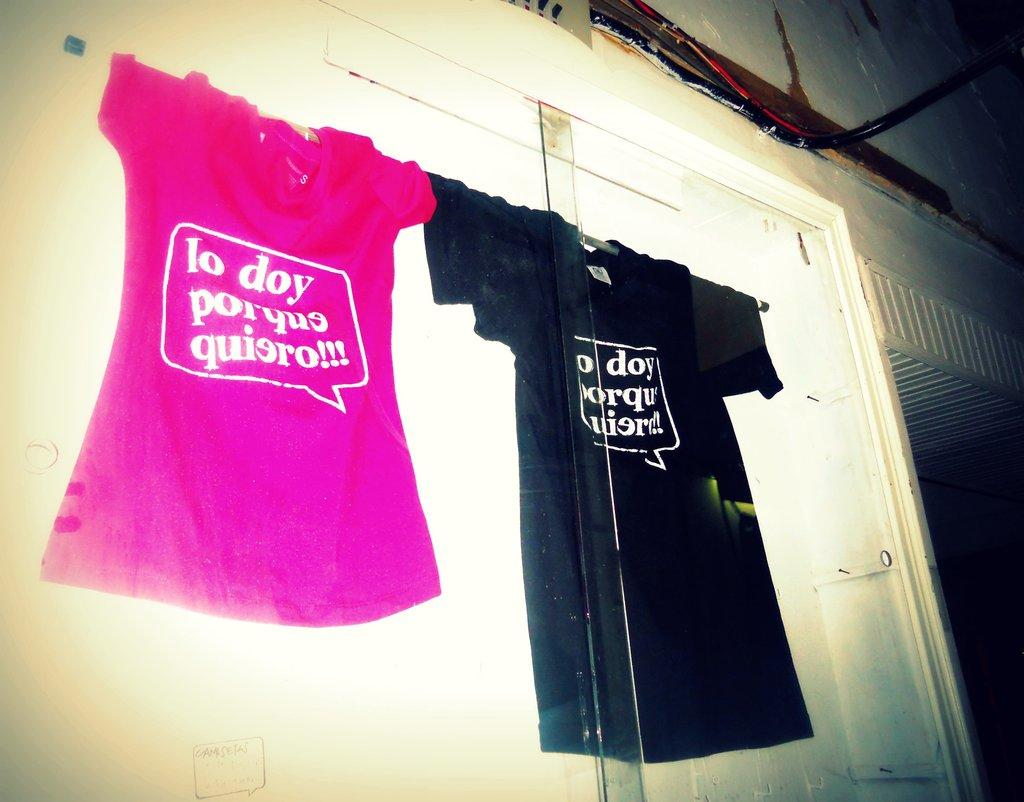Provide a one-sentence caption for the provided image. a pink and a black t shirt hanging together, one of which has lo doy porquo quiero written on it. 